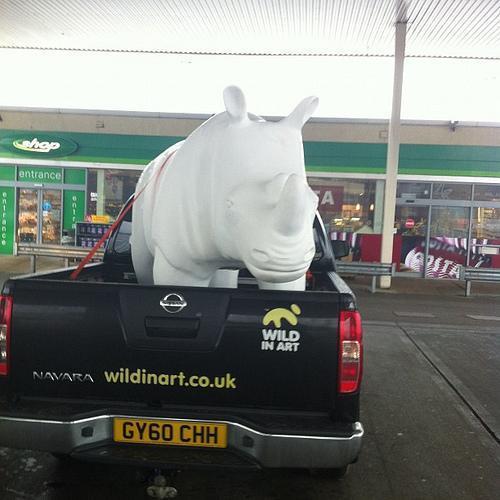How many trucks are shown?
Give a very brief answer. 1. 